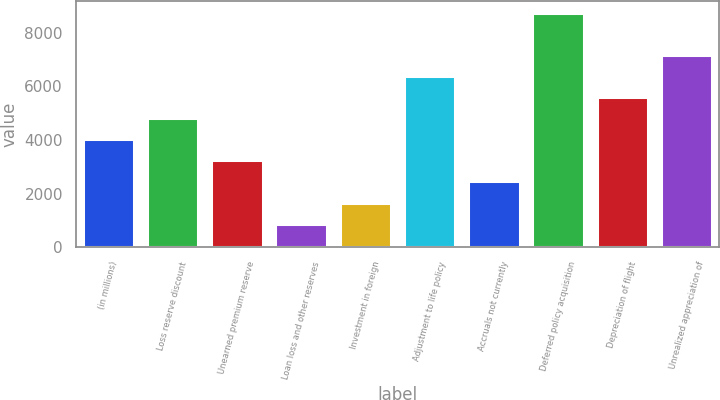<chart> <loc_0><loc_0><loc_500><loc_500><bar_chart><fcel>(in millions)<fcel>Loss reserve discount<fcel>Unearned premium reserve<fcel>Loan loss and other reserves<fcel>Investment in foreign<fcel>Adjustment to life policy<fcel>Accruals not currently<fcel>Deferred policy acquisition<fcel>Depreciation of flight<fcel>Unrealized appreciation of<nl><fcel>4026.5<fcel>4812.4<fcel>3240.6<fcel>882.9<fcel>1668.8<fcel>6384.2<fcel>2454.7<fcel>8741.9<fcel>5598.3<fcel>7170.1<nl></chart> 